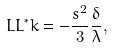Convert formula to latex. <formula><loc_0><loc_0><loc_500><loc_500>L L ^ { * } k = - \frac { s ^ { 2 } } { 3 } \frac { \delta } { \lambda } ,</formula> 